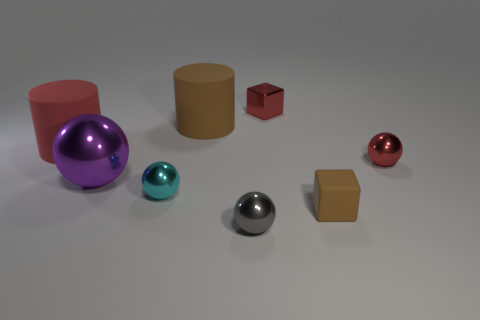There is a tiny ball that is the same color as the tiny metallic block; what is it made of?
Make the answer very short. Metal. What is the shape of the red shiny thing that is behind the big red rubber object?
Offer a very short reply. Cube. There is a red thing that is the same size as the red ball; what is it made of?
Your response must be concise. Metal. What number of objects are small balls behind the large purple metal thing or blocks in front of the small cyan metallic thing?
Offer a very short reply. 2. What is the size of the purple thing that is made of the same material as the red ball?
Ensure brevity in your answer.  Large. What number of shiny objects are either big green cylinders or large red cylinders?
Keep it short and to the point. 0. How big is the brown rubber cylinder?
Offer a terse response. Large. Do the matte block and the gray metallic ball have the same size?
Keep it short and to the point. Yes. What is the material of the cylinder behind the red cylinder?
Offer a very short reply. Rubber. What material is the large purple object that is the same shape as the small gray metal object?
Provide a short and direct response. Metal. 